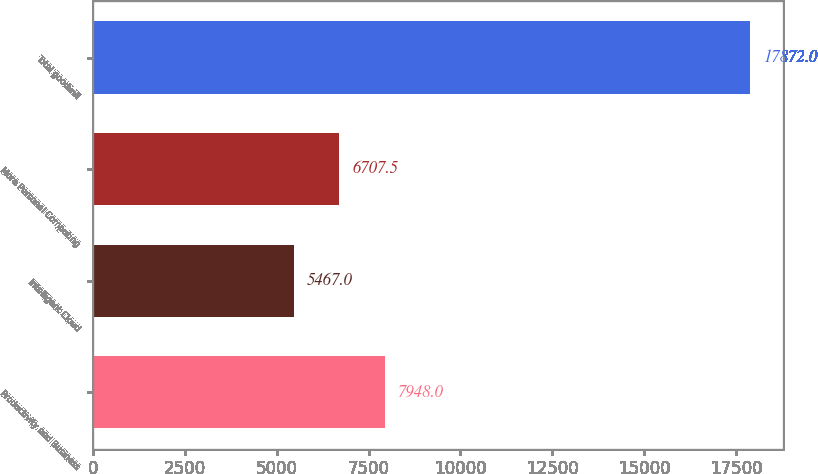Convert chart. <chart><loc_0><loc_0><loc_500><loc_500><bar_chart><fcel>Productivity and Business<fcel>Intelligent Cloud<fcel>More Personal Computing<fcel>Total goodwill<nl><fcel>7948<fcel>5467<fcel>6707.5<fcel>17872<nl></chart> 